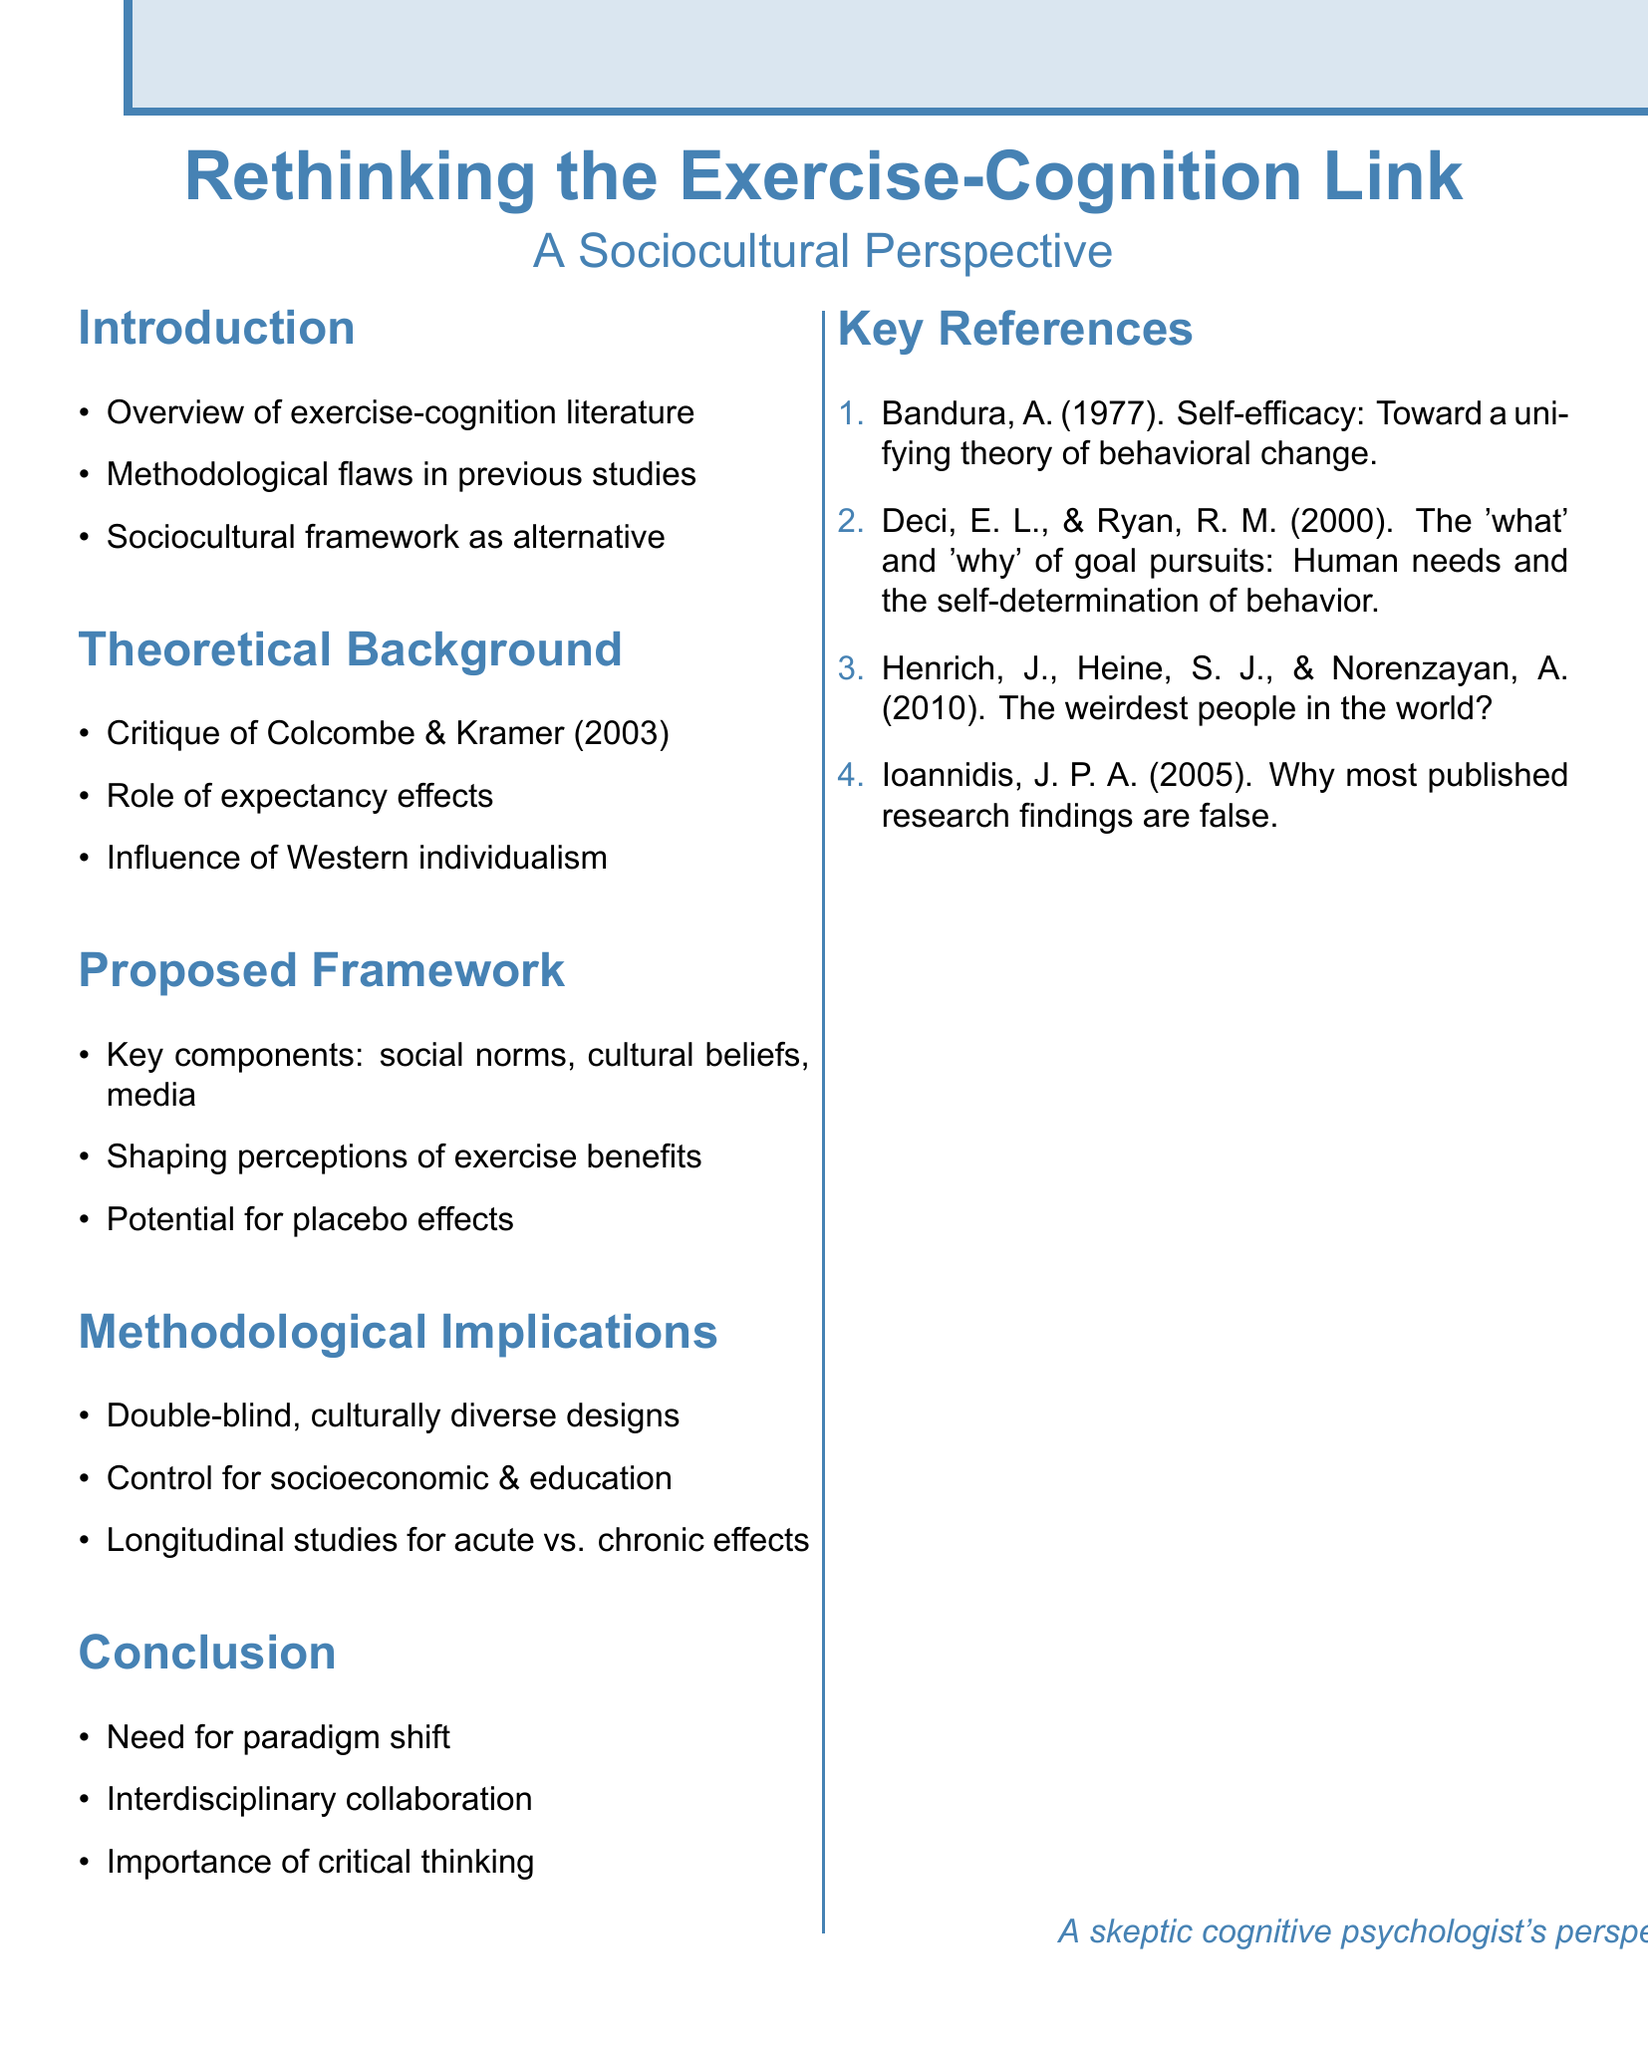what is the title of the document? The title is the main heading of the document, which introduces the topic discussed.
Answer: Rethinking the Exercise-Cognition Link: A Sociocultural Perspective who authored the critique of the meta-analysis in the theoretical background? The reference mentioned in the theoretical background critiques a significant meta-analysis related to the topic, which is by specific authors.
Answer: Colcombe and Kramer what are the key components of the proposed sociocultural framework? This question pertains to specific factors outlined in the document that are integral to the proposed framework.
Answer: social norms, cultural beliefs, and media influence what type of study designs are proposed in the methodological implications? This question refers to the specific research design suggested to enhance validity in research findings on the exercise-cognition link.
Answer: double-blind, culturally diverse study designs what is emphasized in the conclusion regarding research collaboration? The conclusion includes a call for cooperation with other disciplines to better understand the topic's complexity.
Answer: interdisciplinary collaboration how many key references are listed in the document? This asks for the numeric count of references provided to support the concepts discussed.
Answer: four what is the role of expectancy effects in exercise-cognition studies according to the theoretical background? This question focuses on the influence that expectations may have on the outcomes of studies related to exercise and cognition.
Answer: Expectancy effects what shift is needed in exercise-cognition research according to the conclusion? This question pertains to a critical change that the authors believe is essential for the advancement of the field.
Answer: paradigm shift what influences perceptions of exercise benefits as per the proposed framework? This question refers to the factors that shape how individuals view the advantages of exercise according to the document's analysis.
Answer: social norms, cultural beliefs, and media influence 